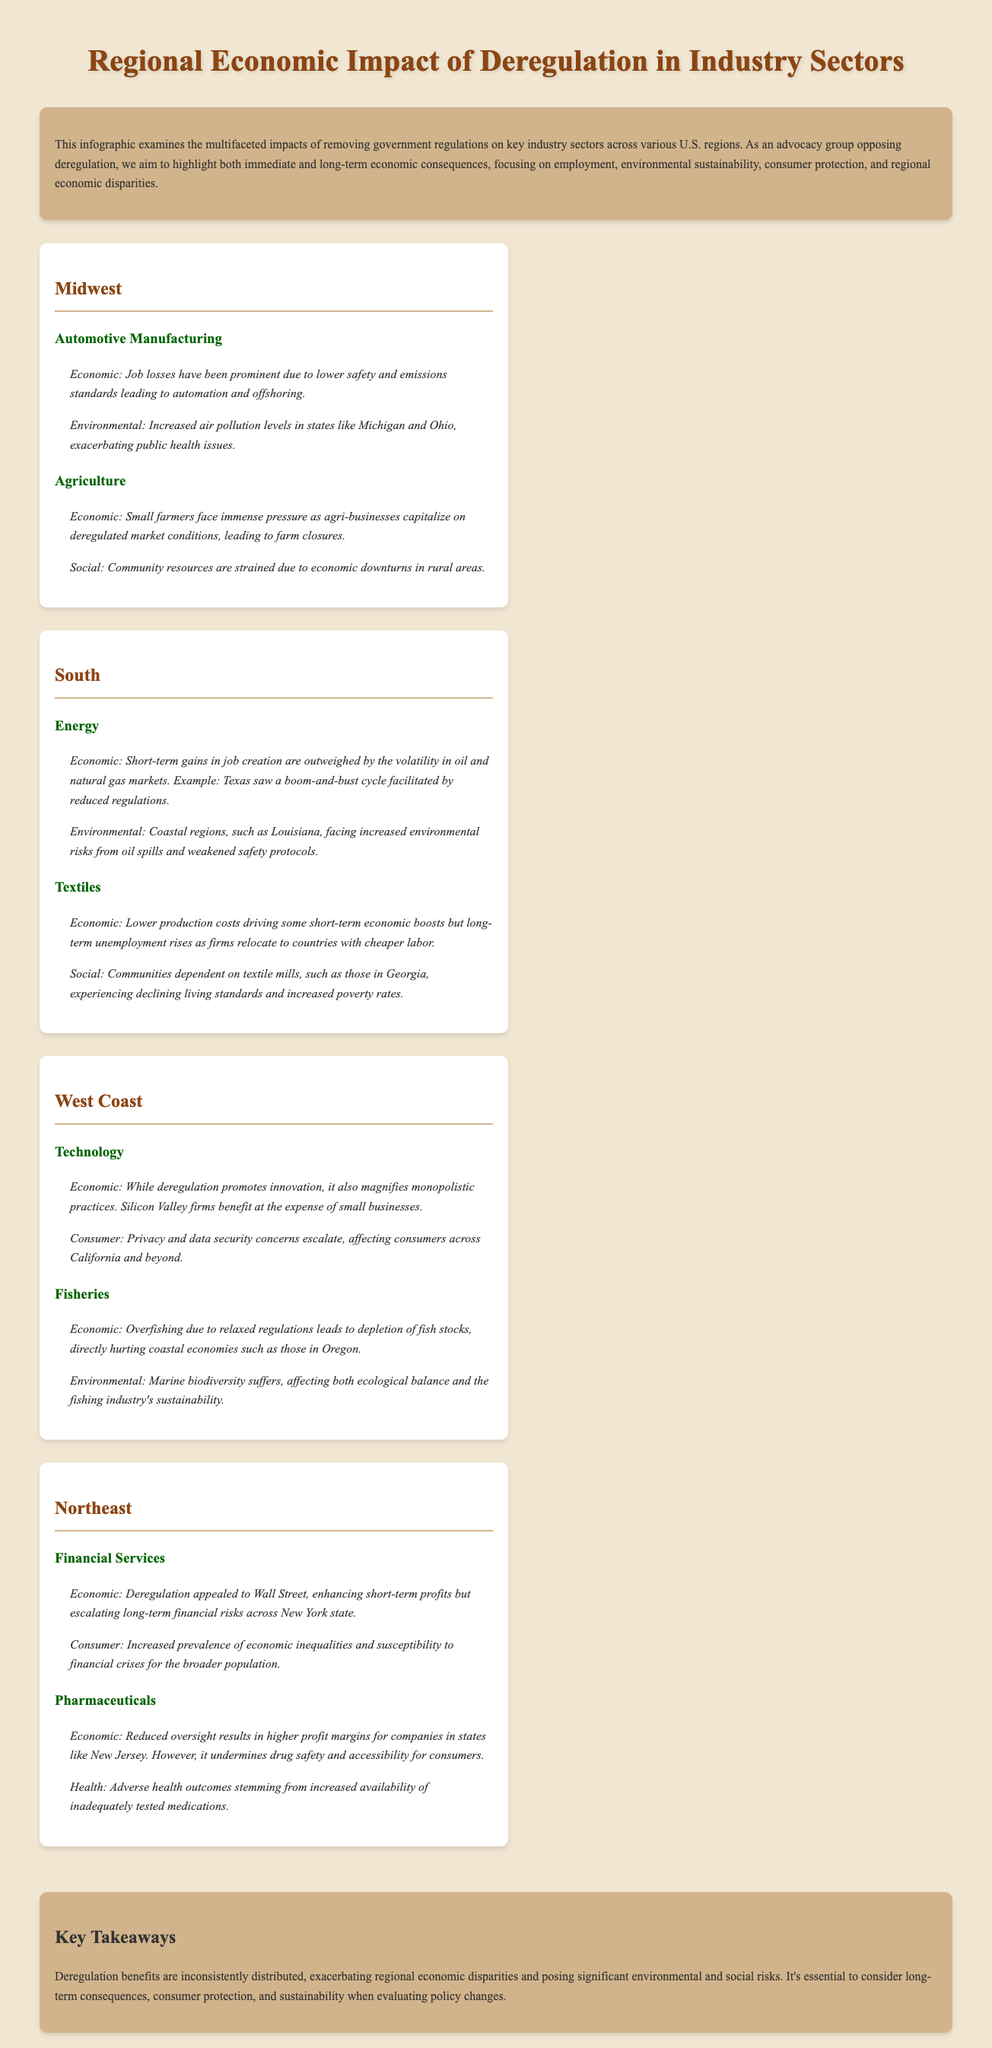What are the two main industry sectors mentioned in the Midwest? The document lists Automotive Manufacturing and Agriculture as the key industry sectors in the Midwest region.
Answer: Automotive Manufacturing, Agriculture What are the economic impacts of deregulation on the Textile industry in the South? The economic impact listed is lower production costs driving short-term economic boosts and long-term unemployment increases.
Answer: Short-term economic boosts, long-term unemployment increases Which region faces increased air pollution levels due to deregulation? The text indicates that the Midwest, particularly states like Michigan and Ohio, faces increased air pollution levels as a result of deregulation.
Answer: Midwest What is a key environmental impact of deregulation in the Fisheries industry on the West Coast? The document states that overfishing due to relaxed regulations leads to depletion of fish stocks, impacting coastal economies.
Answer: Depletion of fish stocks How does deregulation affect consumer protection in the Technology sector on the West Coast? The document notes that privacy and data security concerns escalate, affecting consumers across California and beyond.
Answer: Privacy and data security concerns What is a key takeaway regarding the distribution of deregulation benefits? The takeaway highlights that deregulation benefits are inconsistently distributed, leading to regional economic disparities.
Answer: Inconsistently distributed How do small farmers in the Midwest react to deregulation in Agriculture? The document describes immense pressure on small farmers due to the capitalization of agri-businesses on deregulated market conditions.
Answer: Immense pressure What is the primary health concern raised regarding Pharmaceuticals in the Northeast? The concern noted is adverse health outcomes resulting from increased availability of inadequately tested medications.
Answer: Adverse health outcomes 